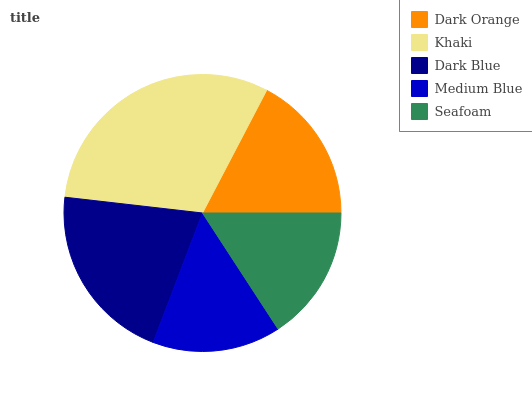Is Medium Blue the minimum?
Answer yes or no. Yes. Is Khaki the maximum?
Answer yes or no. Yes. Is Dark Blue the minimum?
Answer yes or no. No. Is Dark Blue the maximum?
Answer yes or no. No. Is Khaki greater than Dark Blue?
Answer yes or no. Yes. Is Dark Blue less than Khaki?
Answer yes or no. Yes. Is Dark Blue greater than Khaki?
Answer yes or no. No. Is Khaki less than Dark Blue?
Answer yes or no. No. Is Dark Orange the high median?
Answer yes or no. Yes. Is Dark Orange the low median?
Answer yes or no. Yes. Is Khaki the high median?
Answer yes or no. No. Is Dark Blue the low median?
Answer yes or no. No. 